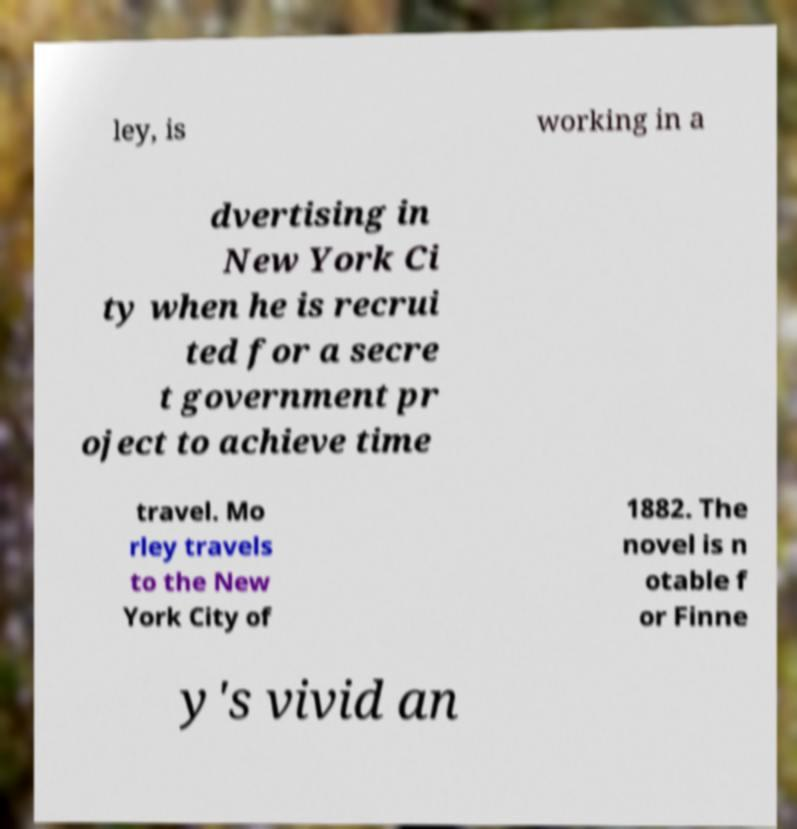For documentation purposes, I need the text within this image transcribed. Could you provide that? ley, is working in a dvertising in New York Ci ty when he is recrui ted for a secre t government pr oject to achieve time travel. Mo rley travels to the New York City of 1882. The novel is n otable f or Finne y's vivid an 